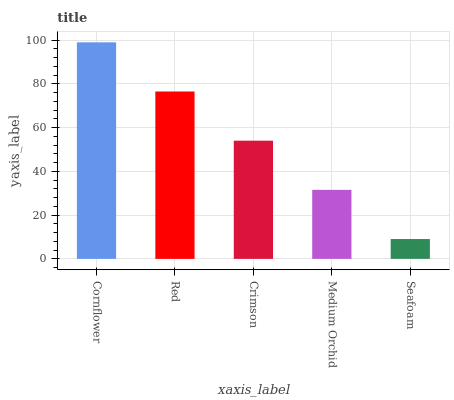Is Seafoam the minimum?
Answer yes or no. Yes. Is Cornflower the maximum?
Answer yes or no. Yes. Is Red the minimum?
Answer yes or no. No. Is Red the maximum?
Answer yes or no. No. Is Cornflower greater than Red?
Answer yes or no. Yes. Is Red less than Cornflower?
Answer yes or no. Yes. Is Red greater than Cornflower?
Answer yes or no. No. Is Cornflower less than Red?
Answer yes or no. No. Is Crimson the high median?
Answer yes or no. Yes. Is Crimson the low median?
Answer yes or no. Yes. Is Red the high median?
Answer yes or no. No. Is Medium Orchid the low median?
Answer yes or no. No. 